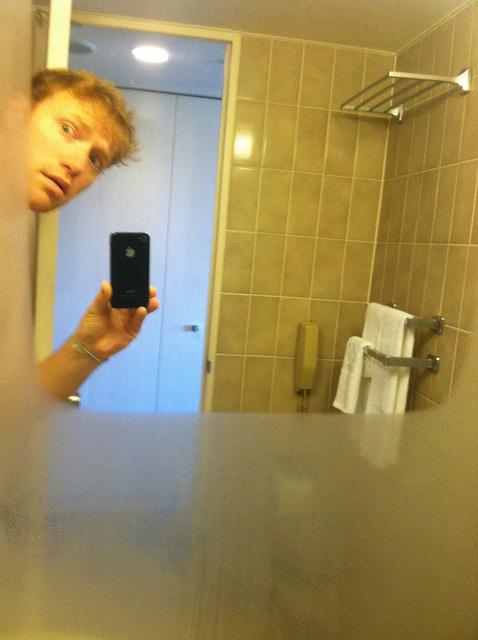Is this selfie being taken in a bathroom?
Write a very short answer. Yes. Where are the towels?
Quick response, please. Rack. Is the door closed?
Quick response, please. No. 